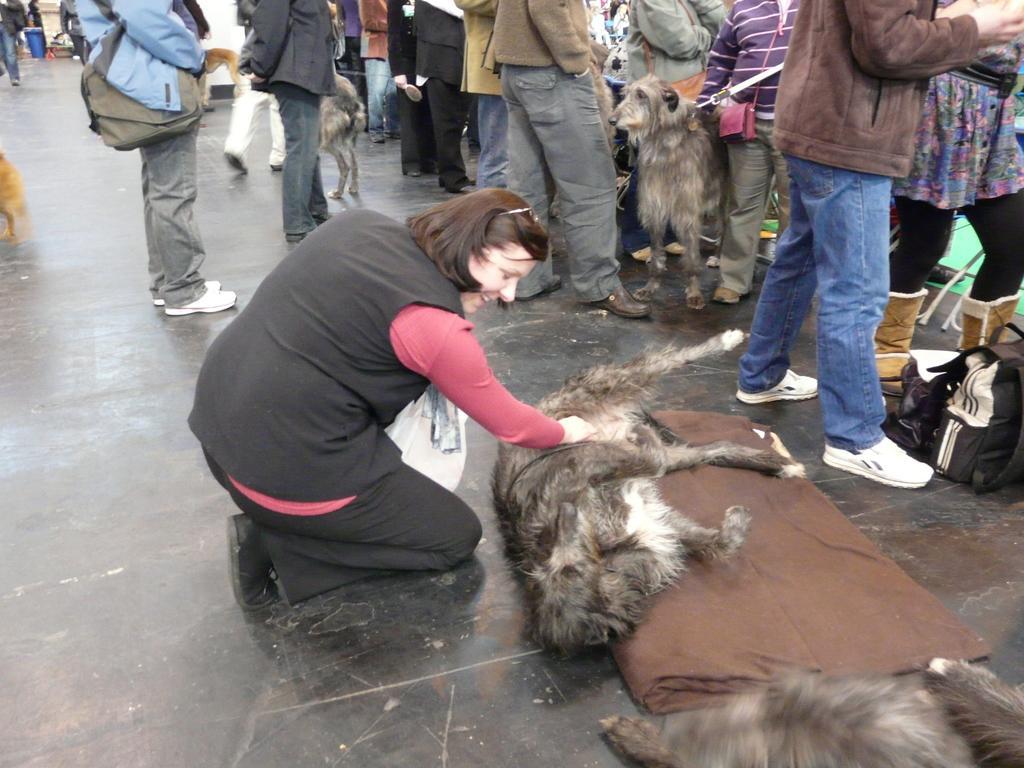Could you give a brief overview of what you see in this image? In this image, we can see group of people are standing ,few dog are there in this image. The middle woman is holding a dog and she is smiling. On right side, we can see few bags and cloth. Few are wearing a bags. 